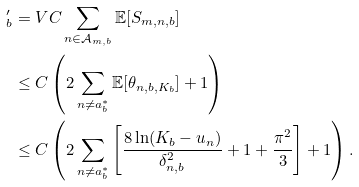<formula> <loc_0><loc_0><loc_500><loc_500>^ { \prime } _ { b } & = V C \sum _ { n \in \mathcal { A } _ { m , b } } \mathbb { E } [ S _ { m , n , b } ] \\ & \leq C \left ( 2 \sum _ { n \neq a _ { b } ^ { * } } \mathbb { E } [ \theta _ { n , b , K _ { b } } ] + 1 \right ) \\ & \leq C \left ( 2 \sum _ { n \neq a _ { b } ^ { * } } \left [ \frac { 8 \ln ( K _ { b } - u _ { n } ) } { \delta ^ { 2 } _ { n , b } } + 1 + \frac { \pi ^ { 2 } } { 3 } \right ] + 1 \right ) .</formula> 